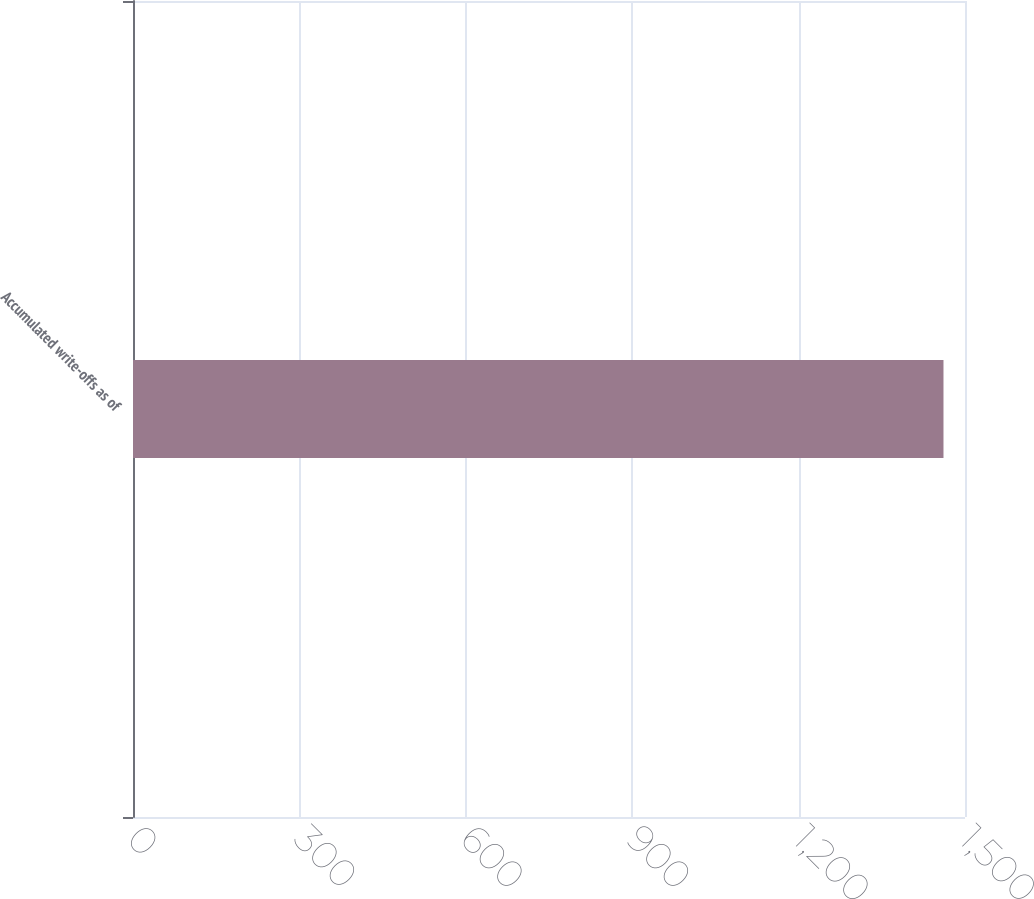Convert chart to OTSL. <chart><loc_0><loc_0><loc_500><loc_500><bar_chart><fcel>Accumulated write-offs as of<nl><fcel>1461.2<nl></chart> 